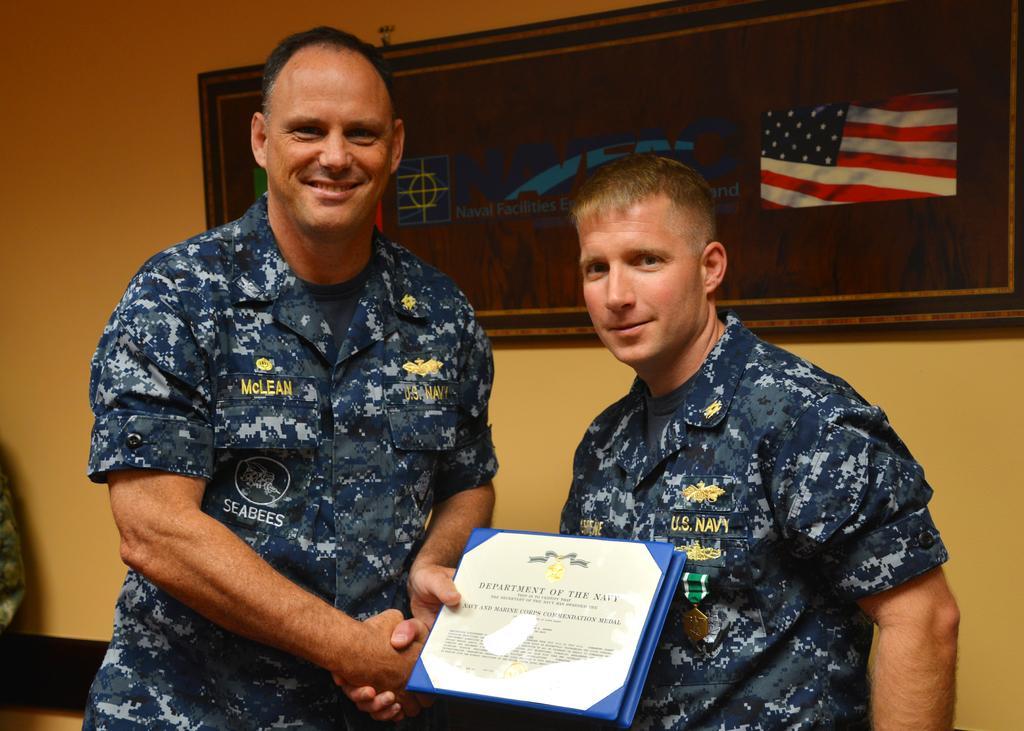Could you give a brief overview of what you see in this image? In this picture we can see two people standing and shaking their hands. We can see a person holding an object visible on the left side. There is some text, an image of a flag and a few things on the board visible on the wall. 